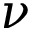<formula> <loc_0><loc_0><loc_500><loc_500>\nu</formula> 